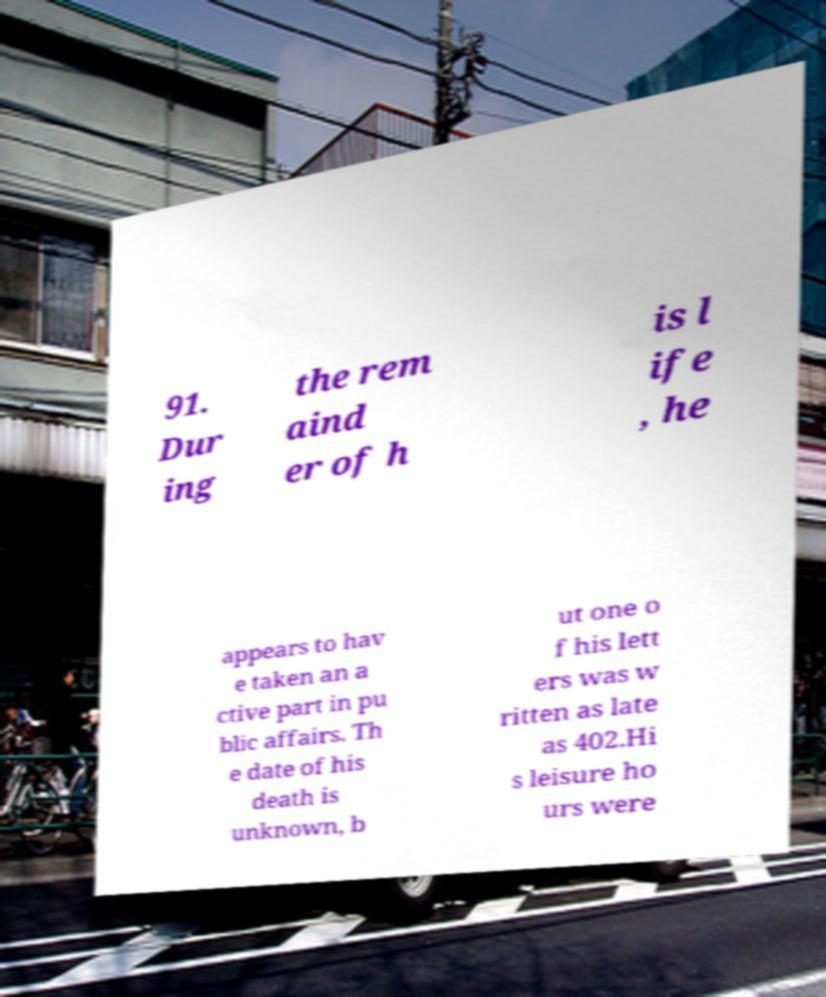There's text embedded in this image that I need extracted. Can you transcribe it verbatim? 91. Dur ing the rem aind er of h is l ife , he appears to hav e taken an a ctive part in pu blic affairs. Th e date of his death is unknown, b ut one o f his lett ers was w ritten as late as 402.Hi s leisure ho urs were 